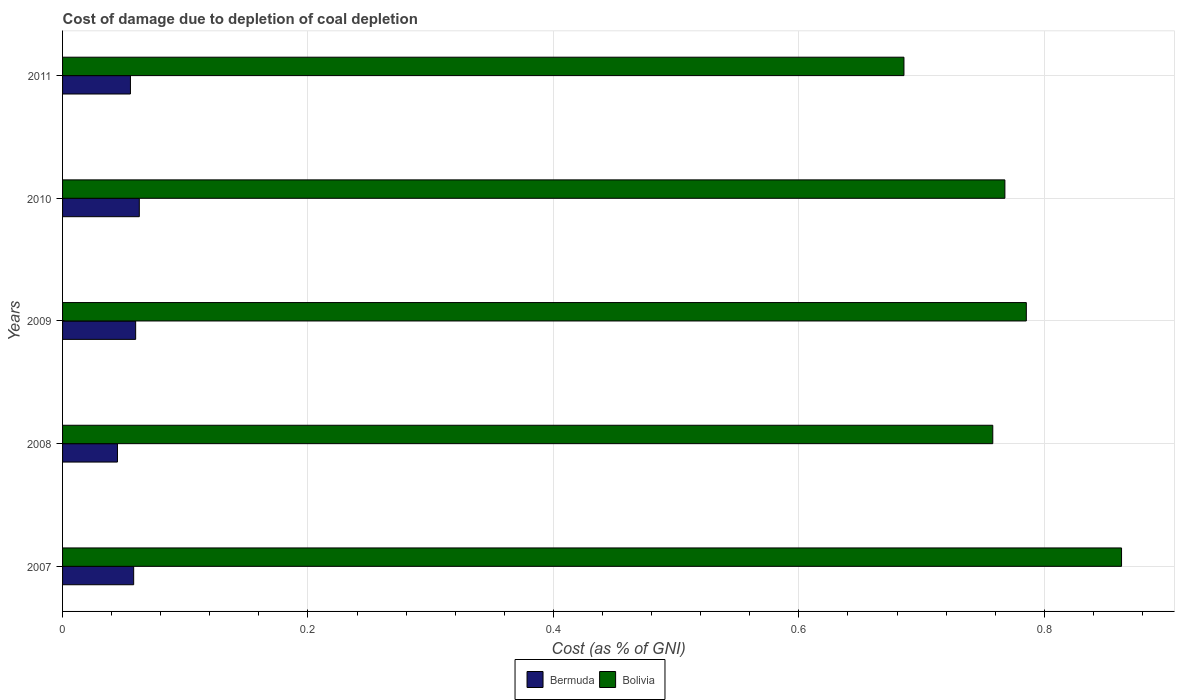How many different coloured bars are there?
Provide a succinct answer. 2. How many groups of bars are there?
Your response must be concise. 5. Are the number of bars on each tick of the Y-axis equal?
Keep it short and to the point. Yes. How many bars are there on the 4th tick from the top?
Give a very brief answer. 2. How many bars are there on the 5th tick from the bottom?
Your response must be concise. 2. What is the label of the 4th group of bars from the top?
Provide a succinct answer. 2008. In how many cases, is the number of bars for a given year not equal to the number of legend labels?
Make the answer very short. 0. What is the cost of damage caused due to coal depletion in Bolivia in 2007?
Keep it short and to the point. 0.86. Across all years, what is the maximum cost of damage caused due to coal depletion in Bermuda?
Provide a succinct answer. 0.06. Across all years, what is the minimum cost of damage caused due to coal depletion in Bermuda?
Make the answer very short. 0.04. In which year was the cost of damage caused due to coal depletion in Bolivia minimum?
Offer a very short reply. 2011. What is the total cost of damage caused due to coal depletion in Bolivia in the graph?
Give a very brief answer. 3.86. What is the difference between the cost of damage caused due to coal depletion in Bolivia in 2007 and that in 2009?
Keep it short and to the point. 0.08. What is the difference between the cost of damage caused due to coal depletion in Bermuda in 2008 and the cost of damage caused due to coal depletion in Bolivia in 2007?
Give a very brief answer. -0.82. What is the average cost of damage caused due to coal depletion in Bermuda per year?
Provide a succinct answer. 0.06. In the year 2011, what is the difference between the cost of damage caused due to coal depletion in Bolivia and cost of damage caused due to coal depletion in Bermuda?
Provide a succinct answer. 0.63. What is the ratio of the cost of damage caused due to coal depletion in Bolivia in 2007 to that in 2008?
Offer a very short reply. 1.14. Is the cost of damage caused due to coal depletion in Bolivia in 2007 less than that in 2011?
Provide a short and direct response. No. Is the difference between the cost of damage caused due to coal depletion in Bolivia in 2008 and 2011 greater than the difference between the cost of damage caused due to coal depletion in Bermuda in 2008 and 2011?
Give a very brief answer. Yes. What is the difference between the highest and the second highest cost of damage caused due to coal depletion in Bolivia?
Ensure brevity in your answer.  0.08. What is the difference between the highest and the lowest cost of damage caused due to coal depletion in Bermuda?
Give a very brief answer. 0.02. Is the sum of the cost of damage caused due to coal depletion in Bolivia in 2007 and 2008 greater than the maximum cost of damage caused due to coal depletion in Bermuda across all years?
Your response must be concise. Yes. What does the 2nd bar from the bottom in 2009 represents?
Ensure brevity in your answer.  Bolivia. How many bars are there?
Make the answer very short. 10. Does the graph contain grids?
Provide a short and direct response. Yes. Where does the legend appear in the graph?
Your response must be concise. Bottom center. How are the legend labels stacked?
Your answer should be very brief. Horizontal. What is the title of the graph?
Provide a succinct answer. Cost of damage due to depletion of coal depletion. What is the label or title of the X-axis?
Keep it short and to the point. Cost (as % of GNI). What is the Cost (as % of GNI) of Bermuda in 2007?
Your answer should be compact. 0.06. What is the Cost (as % of GNI) in Bolivia in 2007?
Offer a very short reply. 0.86. What is the Cost (as % of GNI) of Bermuda in 2008?
Ensure brevity in your answer.  0.04. What is the Cost (as % of GNI) in Bolivia in 2008?
Provide a short and direct response. 0.76. What is the Cost (as % of GNI) in Bermuda in 2009?
Your response must be concise. 0.06. What is the Cost (as % of GNI) of Bolivia in 2009?
Give a very brief answer. 0.79. What is the Cost (as % of GNI) in Bermuda in 2010?
Provide a short and direct response. 0.06. What is the Cost (as % of GNI) of Bolivia in 2010?
Make the answer very short. 0.77. What is the Cost (as % of GNI) in Bermuda in 2011?
Provide a succinct answer. 0.06. What is the Cost (as % of GNI) of Bolivia in 2011?
Offer a very short reply. 0.69. Across all years, what is the maximum Cost (as % of GNI) in Bermuda?
Offer a terse response. 0.06. Across all years, what is the maximum Cost (as % of GNI) of Bolivia?
Provide a short and direct response. 0.86. Across all years, what is the minimum Cost (as % of GNI) in Bermuda?
Offer a very short reply. 0.04. Across all years, what is the minimum Cost (as % of GNI) in Bolivia?
Make the answer very short. 0.69. What is the total Cost (as % of GNI) of Bermuda in the graph?
Your response must be concise. 0.28. What is the total Cost (as % of GNI) in Bolivia in the graph?
Provide a succinct answer. 3.86. What is the difference between the Cost (as % of GNI) in Bermuda in 2007 and that in 2008?
Give a very brief answer. 0.01. What is the difference between the Cost (as % of GNI) in Bolivia in 2007 and that in 2008?
Give a very brief answer. 0.1. What is the difference between the Cost (as % of GNI) in Bermuda in 2007 and that in 2009?
Provide a succinct answer. -0. What is the difference between the Cost (as % of GNI) of Bolivia in 2007 and that in 2009?
Keep it short and to the point. 0.08. What is the difference between the Cost (as % of GNI) in Bermuda in 2007 and that in 2010?
Give a very brief answer. -0. What is the difference between the Cost (as % of GNI) of Bolivia in 2007 and that in 2010?
Your answer should be very brief. 0.1. What is the difference between the Cost (as % of GNI) of Bermuda in 2007 and that in 2011?
Offer a very short reply. 0. What is the difference between the Cost (as % of GNI) in Bolivia in 2007 and that in 2011?
Make the answer very short. 0.18. What is the difference between the Cost (as % of GNI) in Bermuda in 2008 and that in 2009?
Make the answer very short. -0.01. What is the difference between the Cost (as % of GNI) of Bolivia in 2008 and that in 2009?
Keep it short and to the point. -0.03. What is the difference between the Cost (as % of GNI) in Bermuda in 2008 and that in 2010?
Your response must be concise. -0.02. What is the difference between the Cost (as % of GNI) of Bolivia in 2008 and that in 2010?
Ensure brevity in your answer.  -0.01. What is the difference between the Cost (as % of GNI) of Bermuda in 2008 and that in 2011?
Offer a very short reply. -0.01. What is the difference between the Cost (as % of GNI) of Bolivia in 2008 and that in 2011?
Offer a terse response. 0.07. What is the difference between the Cost (as % of GNI) in Bermuda in 2009 and that in 2010?
Keep it short and to the point. -0. What is the difference between the Cost (as % of GNI) of Bolivia in 2009 and that in 2010?
Provide a succinct answer. 0.02. What is the difference between the Cost (as % of GNI) in Bermuda in 2009 and that in 2011?
Your answer should be compact. 0. What is the difference between the Cost (as % of GNI) of Bolivia in 2009 and that in 2011?
Make the answer very short. 0.1. What is the difference between the Cost (as % of GNI) in Bermuda in 2010 and that in 2011?
Make the answer very short. 0.01. What is the difference between the Cost (as % of GNI) of Bolivia in 2010 and that in 2011?
Provide a short and direct response. 0.08. What is the difference between the Cost (as % of GNI) of Bermuda in 2007 and the Cost (as % of GNI) of Bolivia in 2008?
Give a very brief answer. -0.7. What is the difference between the Cost (as % of GNI) in Bermuda in 2007 and the Cost (as % of GNI) in Bolivia in 2009?
Keep it short and to the point. -0.73. What is the difference between the Cost (as % of GNI) of Bermuda in 2007 and the Cost (as % of GNI) of Bolivia in 2010?
Offer a terse response. -0.71. What is the difference between the Cost (as % of GNI) of Bermuda in 2007 and the Cost (as % of GNI) of Bolivia in 2011?
Offer a terse response. -0.63. What is the difference between the Cost (as % of GNI) of Bermuda in 2008 and the Cost (as % of GNI) of Bolivia in 2009?
Provide a succinct answer. -0.74. What is the difference between the Cost (as % of GNI) in Bermuda in 2008 and the Cost (as % of GNI) in Bolivia in 2010?
Ensure brevity in your answer.  -0.72. What is the difference between the Cost (as % of GNI) in Bermuda in 2008 and the Cost (as % of GNI) in Bolivia in 2011?
Offer a terse response. -0.64. What is the difference between the Cost (as % of GNI) in Bermuda in 2009 and the Cost (as % of GNI) in Bolivia in 2010?
Give a very brief answer. -0.71. What is the difference between the Cost (as % of GNI) in Bermuda in 2009 and the Cost (as % of GNI) in Bolivia in 2011?
Your answer should be very brief. -0.63. What is the difference between the Cost (as % of GNI) in Bermuda in 2010 and the Cost (as % of GNI) in Bolivia in 2011?
Keep it short and to the point. -0.62. What is the average Cost (as % of GNI) in Bermuda per year?
Provide a succinct answer. 0.06. What is the average Cost (as % of GNI) in Bolivia per year?
Your answer should be compact. 0.77. In the year 2007, what is the difference between the Cost (as % of GNI) of Bermuda and Cost (as % of GNI) of Bolivia?
Your response must be concise. -0.81. In the year 2008, what is the difference between the Cost (as % of GNI) of Bermuda and Cost (as % of GNI) of Bolivia?
Your answer should be compact. -0.71. In the year 2009, what is the difference between the Cost (as % of GNI) in Bermuda and Cost (as % of GNI) in Bolivia?
Your answer should be very brief. -0.73. In the year 2010, what is the difference between the Cost (as % of GNI) of Bermuda and Cost (as % of GNI) of Bolivia?
Your response must be concise. -0.71. In the year 2011, what is the difference between the Cost (as % of GNI) of Bermuda and Cost (as % of GNI) of Bolivia?
Provide a short and direct response. -0.63. What is the ratio of the Cost (as % of GNI) in Bermuda in 2007 to that in 2008?
Your answer should be very brief. 1.3. What is the ratio of the Cost (as % of GNI) in Bolivia in 2007 to that in 2008?
Provide a succinct answer. 1.14. What is the ratio of the Cost (as % of GNI) of Bermuda in 2007 to that in 2009?
Keep it short and to the point. 0.97. What is the ratio of the Cost (as % of GNI) of Bolivia in 2007 to that in 2009?
Offer a very short reply. 1.1. What is the ratio of the Cost (as % of GNI) in Bermuda in 2007 to that in 2010?
Give a very brief answer. 0.93. What is the ratio of the Cost (as % of GNI) in Bolivia in 2007 to that in 2010?
Your response must be concise. 1.12. What is the ratio of the Cost (as % of GNI) in Bermuda in 2007 to that in 2011?
Offer a very short reply. 1.05. What is the ratio of the Cost (as % of GNI) of Bolivia in 2007 to that in 2011?
Your response must be concise. 1.26. What is the ratio of the Cost (as % of GNI) of Bermuda in 2008 to that in 2009?
Make the answer very short. 0.75. What is the ratio of the Cost (as % of GNI) of Bolivia in 2008 to that in 2009?
Make the answer very short. 0.97. What is the ratio of the Cost (as % of GNI) in Bermuda in 2008 to that in 2010?
Your answer should be very brief. 0.72. What is the ratio of the Cost (as % of GNI) of Bolivia in 2008 to that in 2010?
Offer a terse response. 0.99. What is the ratio of the Cost (as % of GNI) of Bermuda in 2008 to that in 2011?
Provide a succinct answer. 0.81. What is the ratio of the Cost (as % of GNI) in Bolivia in 2008 to that in 2011?
Your response must be concise. 1.11. What is the ratio of the Cost (as % of GNI) of Bolivia in 2009 to that in 2010?
Keep it short and to the point. 1.02. What is the ratio of the Cost (as % of GNI) in Bermuda in 2009 to that in 2011?
Give a very brief answer. 1.08. What is the ratio of the Cost (as % of GNI) in Bolivia in 2009 to that in 2011?
Ensure brevity in your answer.  1.15. What is the ratio of the Cost (as % of GNI) in Bermuda in 2010 to that in 2011?
Offer a terse response. 1.13. What is the ratio of the Cost (as % of GNI) of Bolivia in 2010 to that in 2011?
Provide a short and direct response. 1.12. What is the difference between the highest and the second highest Cost (as % of GNI) in Bermuda?
Keep it short and to the point. 0. What is the difference between the highest and the second highest Cost (as % of GNI) in Bolivia?
Provide a succinct answer. 0.08. What is the difference between the highest and the lowest Cost (as % of GNI) in Bermuda?
Offer a very short reply. 0.02. What is the difference between the highest and the lowest Cost (as % of GNI) of Bolivia?
Your response must be concise. 0.18. 